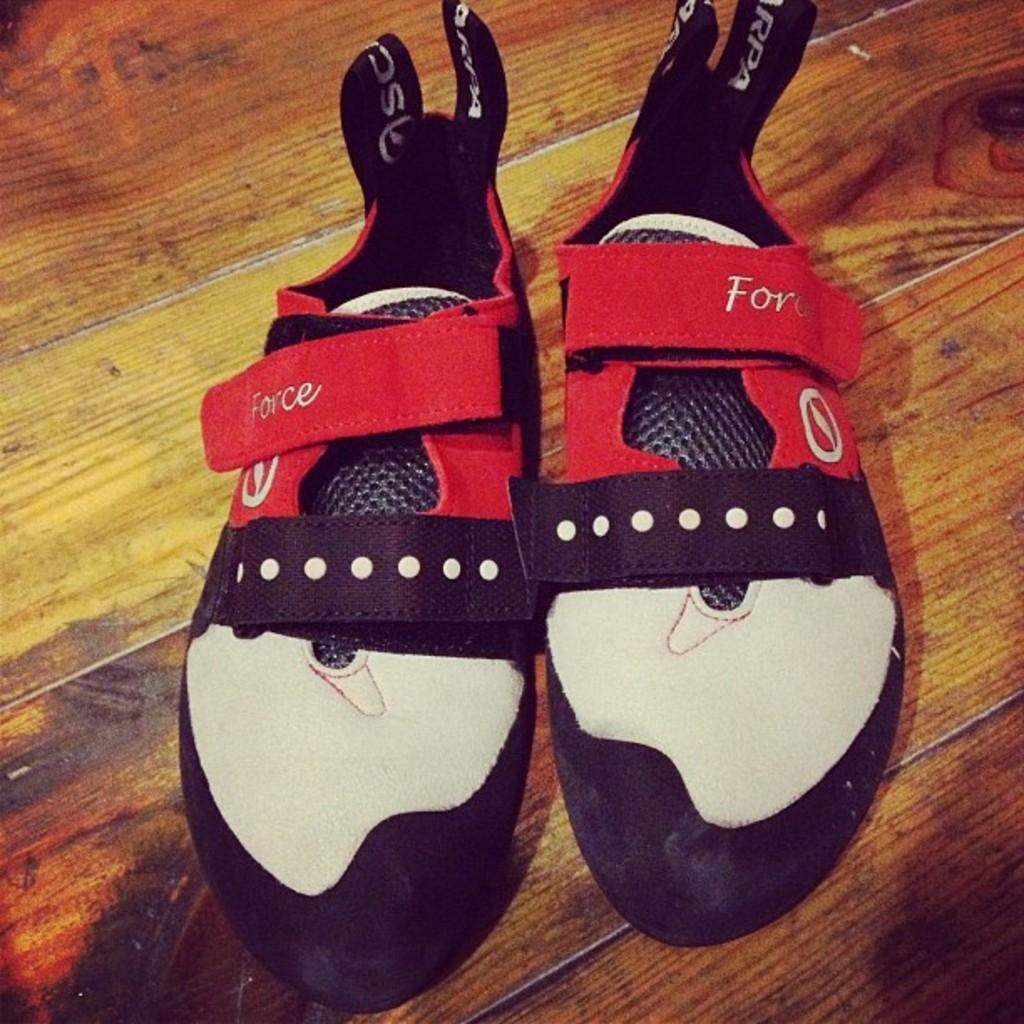How would you summarize this image in a sentence or two? In the image we can see there are shoes kept on the floor. 